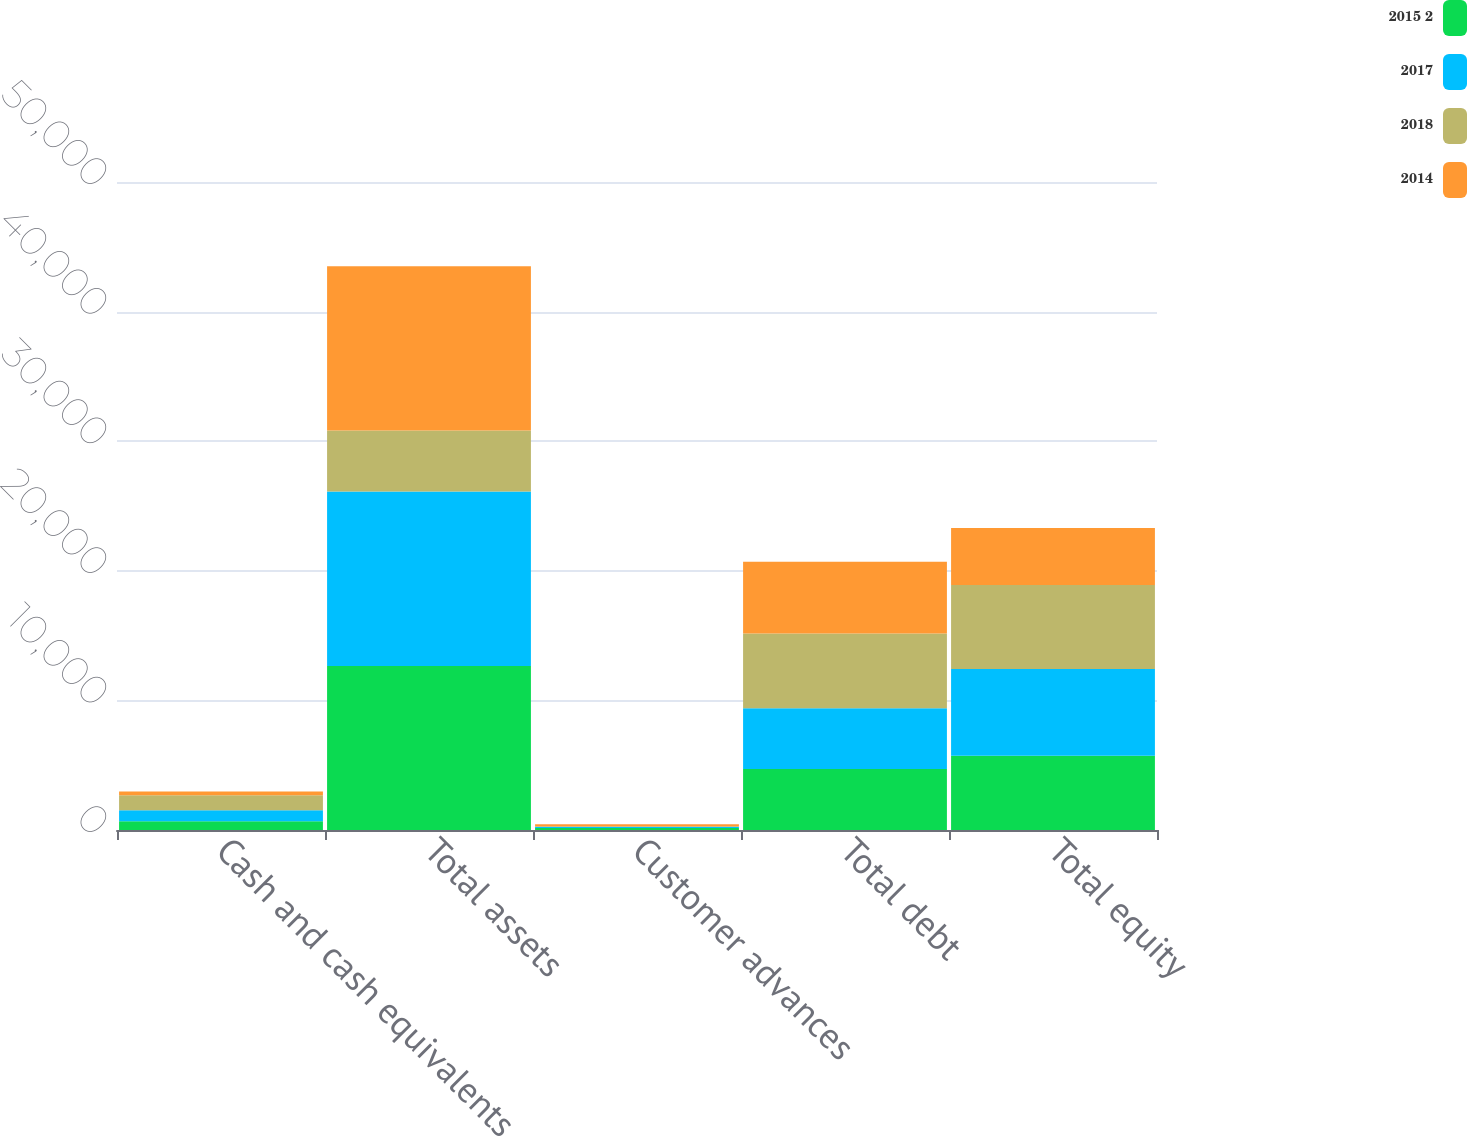Convert chart. <chart><loc_0><loc_0><loc_500><loc_500><stacked_bar_chart><ecel><fcel>Cash and cash equivalents<fcel>Total assets<fcel>Customer advances<fcel>Total debt<fcel>Total equity<nl><fcel>2015 2<fcel>682<fcel>12661<fcel>149<fcel>4698<fcel>5731<nl><fcel>2017<fcel>835<fcel>13463<fcel>89<fcel>4692<fcel>6684<nl><fcel>2018<fcel>1164<fcel>4692<fcel>42<fcel>5778<fcel>6492<nl><fcel>2014<fcel>286<fcel>12683<fcel>162<fcel>5537<fcel>4387<nl></chart> 